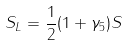<formula> <loc_0><loc_0><loc_500><loc_500>S _ { L } = \frac { 1 } { 2 } ( 1 + \gamma _ { 5 } ) S</formula> 